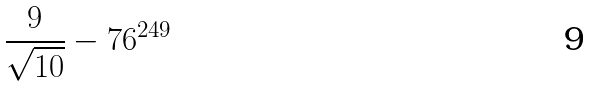Convert formula to latex. <formula><loc_0><loc_0><loc_500><loc_500>\frac { 9 } { \sqrt { 1 0 } } - 7 6 ^ { 2 4 9 }</formula> 